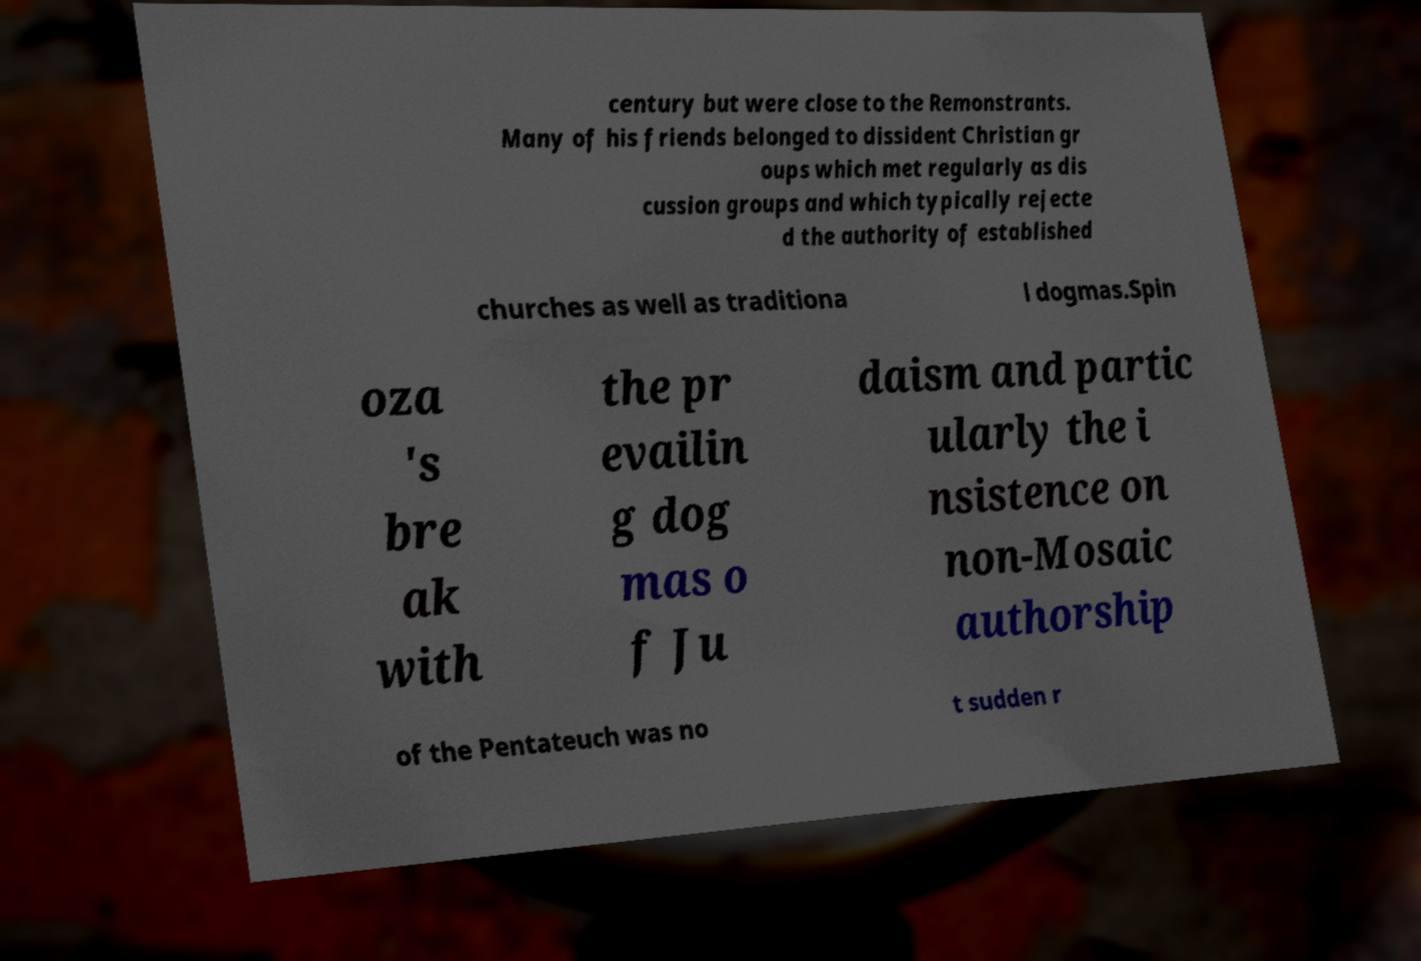I need the written content from this picture converted into text. Can you do that? century but were close to the Remonstrants. Many of his friends belonged to dissident Christian gr oups which met regularly as dis cussion groups and which typically rejecte d the authority of established churches as well as traditiona l dogmas.Spin oza 's bre ak with the pr evailin g dog mas o f Ju daism and partic ularly the i nsistence on non-Mosaic authorship of the Pentateuch was no t sudden r 